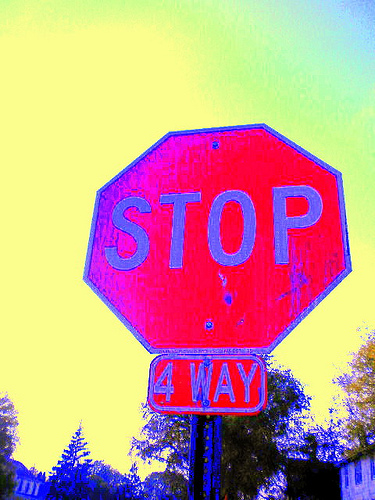Identify the text displayed in this image. STOP 14 WAY 